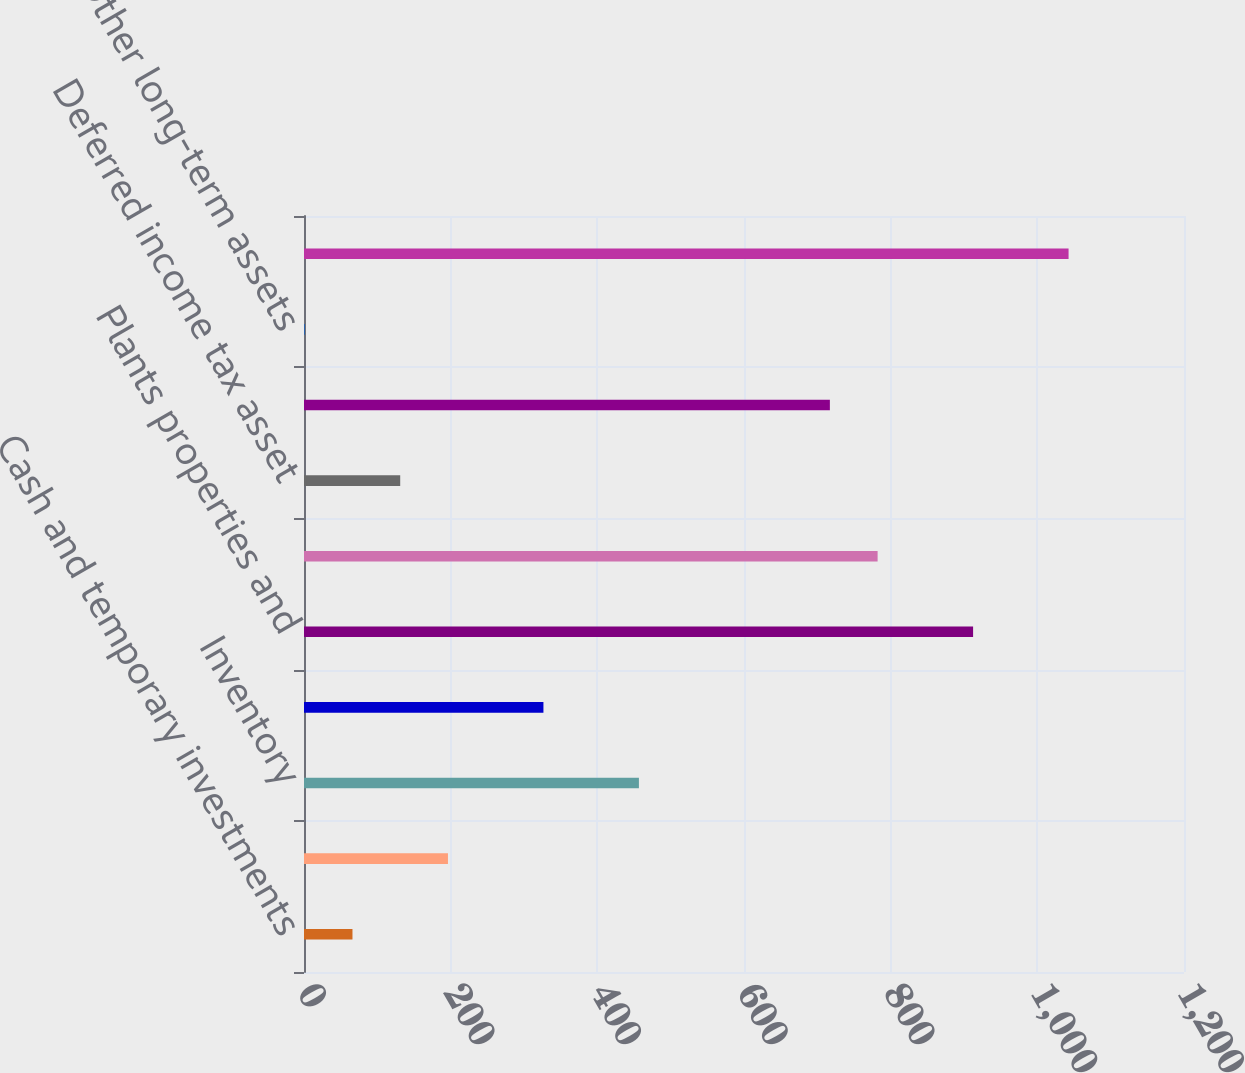Convert chart. <chart><loc_0><loc_0><loc_500><loc_500><bar_chart><fcel>Cash and temporary investments<fcel>Accounts and notes receivable<fcel>Inventory<fcel>Other current assets<fcel>Plants properties and<fcel>Goodwill<fcel>Deferred income tax asset<fcel>Other intangible assets<fcel>Other long-term assets<fcel>Total assets acquired<nl><fcel>66.1<fcel>196.3<fcel>456.7<fcel>326.5<fcel>912.4<fcel>782.2<fcel>131.2<fcel>717.1<fcel>1<fcel>1042.6<nl></chart> 